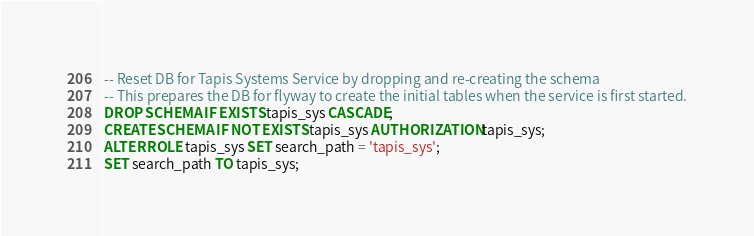<code> <loc_0><loc_0><loc_500><loc_500><_SQL_>-- Reset DB for Tapis Systems Service by dropping and re-creating the schema
-- This prepares the DB for flyway to create the initial tables when the service is first started.
DROP SCHEMA IF EXISTS tapis_sys CASCADE;
CREATE SCHEMA IF NOT EXISTS tapis_sys AUTHORIZATION tapis_sys;
ALTER ROLE tapis_sys SET search_path = 'tapis_sys';
SET search_path TO tapis_sys;
</code> 